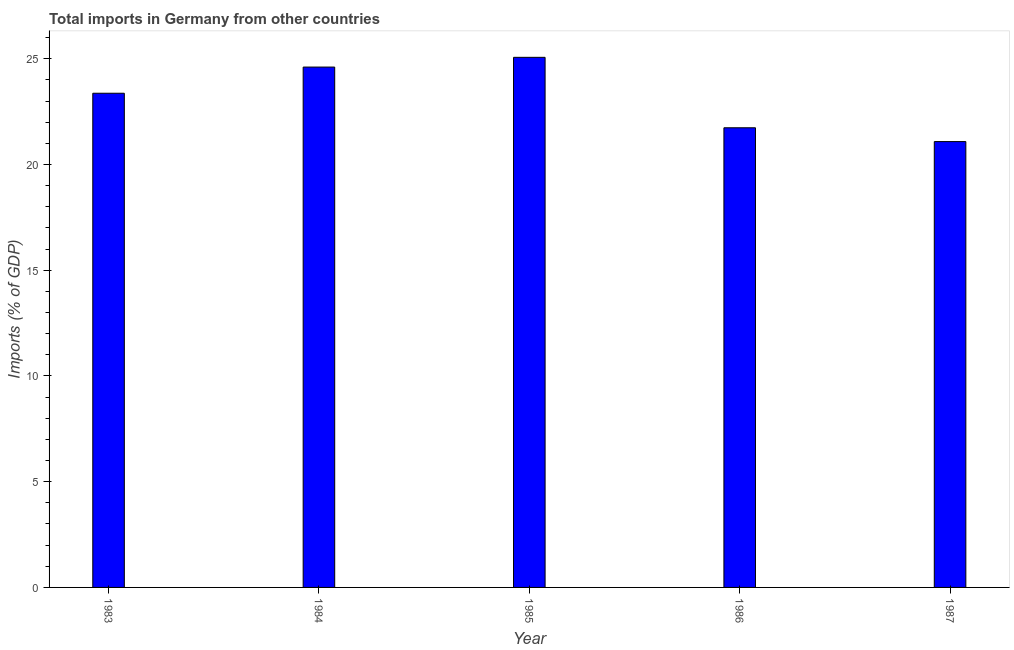Does the graph contain grids?
Your answer should be very brief. No. What is the title of the graph?
Ensure brevity in your answer.  Total imports in Germany from other countries. What is the label or title of the Y-axis?
Offer a terse response. Imports (% of GDP). What is the total imports in 1984?
Make the answer very short. 24.61. Across all years, what is the maximum total imports?
Offer a very short reply. 25.07. Across all years, what is the minimum total imports?
Provide a succinct answer. 21.09. In which year was the total imports minimum?
Offer a very short reply. 1987. What is the sum of the total imports?
Provide a short and direct response. 115.88. What is the difference between the total imports in 1984 and 1985?
Your answer should be very brief. -0.46. What is the average total imports per year?
Give a very brief answer. 23.18. What is the median total imports?
Give a very brief answer. 23.37. What is the ratio of the total imports in 1984 to that in 1987?
Provide a short and direct response. 1.17. Is the difference between the total imports in 1983 and 1984 greater than the difference between any two years?
Your answer should be very brief. No. What is the difference between the highest and the second highest total imports?
Offer a very short reply. 0.46. What is the difference between the highest and the lowest total imports?
Provide a succinct answer. 3.99. In how many years, is the total imports greater than the average total imports taken over all years?
Provide a succinct answer. 3. What is the difference between two consecutive major ticks on the Y-axis?
Offer a terse response. 5. What is the Imports (% of GDP) in 1983?
Keep it short and to the point. 23.37. What is the Imports (% of GDP) of 1984?
Your response must be concise. 24.61. What is the Imports (% of GDP) in 1985?
Ensure brevity in your answer.  25.07. What is the Imports (% of GDP) in 1986?
Offer a terse response. 21.74. What is the Imports (% of GDP) in 1987?
Your answer should be compact. 21.09. What is the difference between the Imports (% of GDP) in 1983 and 1984?
Keep it short and to the point. -1.24. What is the difference between the Imports (% of GDP) in 1983 and 1985?
Ensure brevity in your answer.  -1.7. What is the difference between the Imports (% of GDP) in 1983 and 1986?
Give a very brief answer. 1.63. What is the difference between the Imports (% of GDP) in 1983 and 1987?
Your response must be concise. 2.29. What is the difference between the Imports (% of GDP) in 1984 and 1985?
Offer a very short reply. -0.46. What is the difference between the Imports (% of GDP) in 1984 and 1986?
Your answer should be compact. 2.87. What is the difference between the Imports (% of GDP) in 1984 and 1987?
Ensure brevity in your answer.  3.52. What is the difference between the Imports (% of GDP) in 1985 and 1986?
Your answer should be compact. 3.33. What is the difference between the Imports (% of GDP) in 1985 and 1987?
Your response must be concise. 3.99. What is the difference between the Imports (% of GDP) in 1986 and 1987?
Your answer should be compact. 0.65. What is the ratio of the Imports (% of GDP) in 1983 to that in 1984?
Give a very brief answer. 0.95. What is the ratio of the Imports (% of GDP) in 1983 to that in 1985?
Give a very brief answer. 0.93. What is the ratio of the Imports (% of GDP) in 1983 to that in 1986?
Your answer should be compact. 1.07. What is the ratio of the Imports (% of GDP) in 1983 to that in 1987?
Your response must be concise. 1.11. What is the ratio of the Imports (% of GDP) in 1984 to that in 1985?
Offer a terse response. 0.98. What is the ratio of the Imports (% of GDP) in 1984 to that in 1986?
Your response must be concise. 1.13. What is the ratio of the Imports (% of GDP) in 1984 to that in 1987?
Offer a terse response. 1.17. What is the ratio of the Imports (% of GDP) in 1985 to that in 1986?
Offer a terse response. 1.15. What is the ratio of the Imports (% of GDP) in 1985 to that in 1987?
Give a very brief answer. 1.19. What is the ratio of the Imports (% of GDP) in 1986 to that in 1987?
Provide a succinct answer. 1.03. 